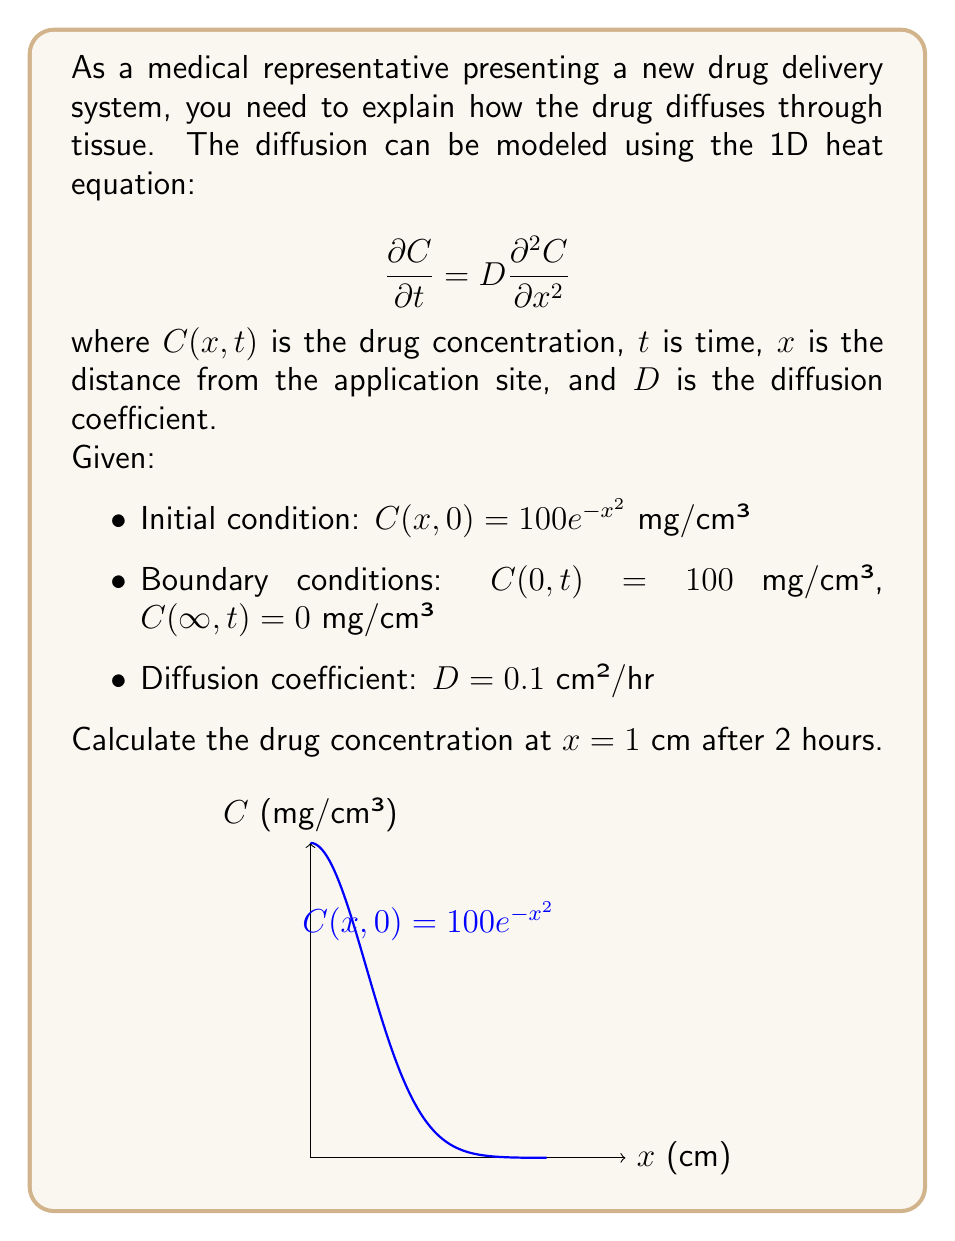Help me with this question. To solve this problem, we can use the fundamental solution of the heat equation, also known as the Green's function:

$$C(x,t) = \frac{1}{\sqrt{4\pi Dt}} \int_{-\infty}^{\infty} C(y,0) \exp\left(-\frac{(x-y)^2}{4Dt}\right) dy + 100 \text{erfc}\left(\frac{x}{\sqrt{4Dt}}\right)$$

Where erfc is the complementary error function.

Step 1: Substitute the given values:
- $x = 1$ cm
- $t = 2$ hours
- $D = 0.1$ cm²/hr

Step 2: Calculate the integral part:
$$\frac{1}{\sqrt{4\pi(0.1)(2)}} \int_{-\infty}^{\infty} 100e^{-y^2} \exp\left(-\frac{(1-y)^2}{4(0.1)(2)}\right) dy$$

Step 3: Simplify the integral:
$$\frac{100}{\sqrt{0.8\pi}} \int_{-\infty}^{\infty} \exp\left(-y^2 - \frac{(1-y)^2}{0.8}\right) dy$$

Step 4: This integral can be evaluated numerically, resulting in approximately 27.95 mg/cm³.

Step 5: Calculate the boundary condition contribution:
$$100 \text{erfc}\left(\frac{1}{\sqrt{4(0.1)(2)}}\right) \approx 15.73 \text{ mg/cm³}$$

Step 6: Sum the results from steps 4 and 5:
$$C(1,2) \approx 27.95 + 15.73 = 43.68 \text{ mg/cm³}$$
Answer: 43.68 mg/cm³ 